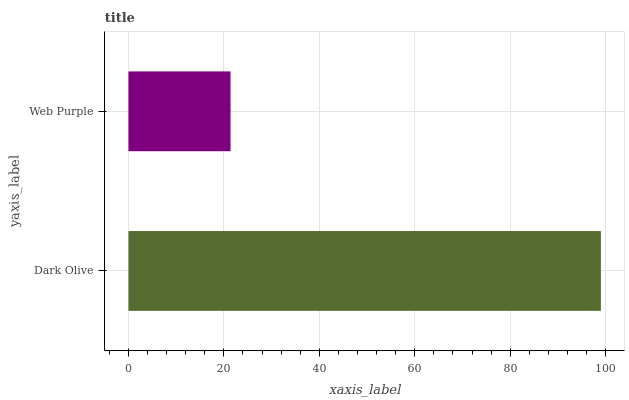Is Web Purple the minimum?
Answer yes or no. Yes. Is Dark Olive the maximum?
Answer yes or no. Yes. Is Web Purple the maximum?
Answer yes or no. No. Is Dark Olive greater than Web Purple?
Answer yes or no. Yes. Is Web Purple less than Dark Olive?
Answer yes or no. Yes. Is Web Purple greater than Dark Olive?
Answer yes or no. No. Is Dark Olive less than Web Purple?
Answer yes or no. No. Is Dark Olive the high median?
Answer yes or no. Yes. Is Web Purple the low median?
Answer yes or no. Yes. Is Web Purple the high median?
Answer yes or no. No. Is Dark Olive the low median?
Answer yes or no. No. 